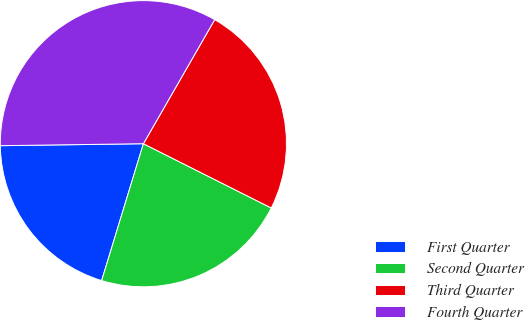Convert chart to OTSL. <chart><loc_0><loc_0><loc_500><loc_500><pie_chart><fcel>First Quarter<fcel>Second Quarter<fcel>Third Quarter<fcel>Fourth Quarter<nl><fcel>20.07%<fcel>22.3%<fcel>24.11%<fcel>33.52%<nl></chart> 